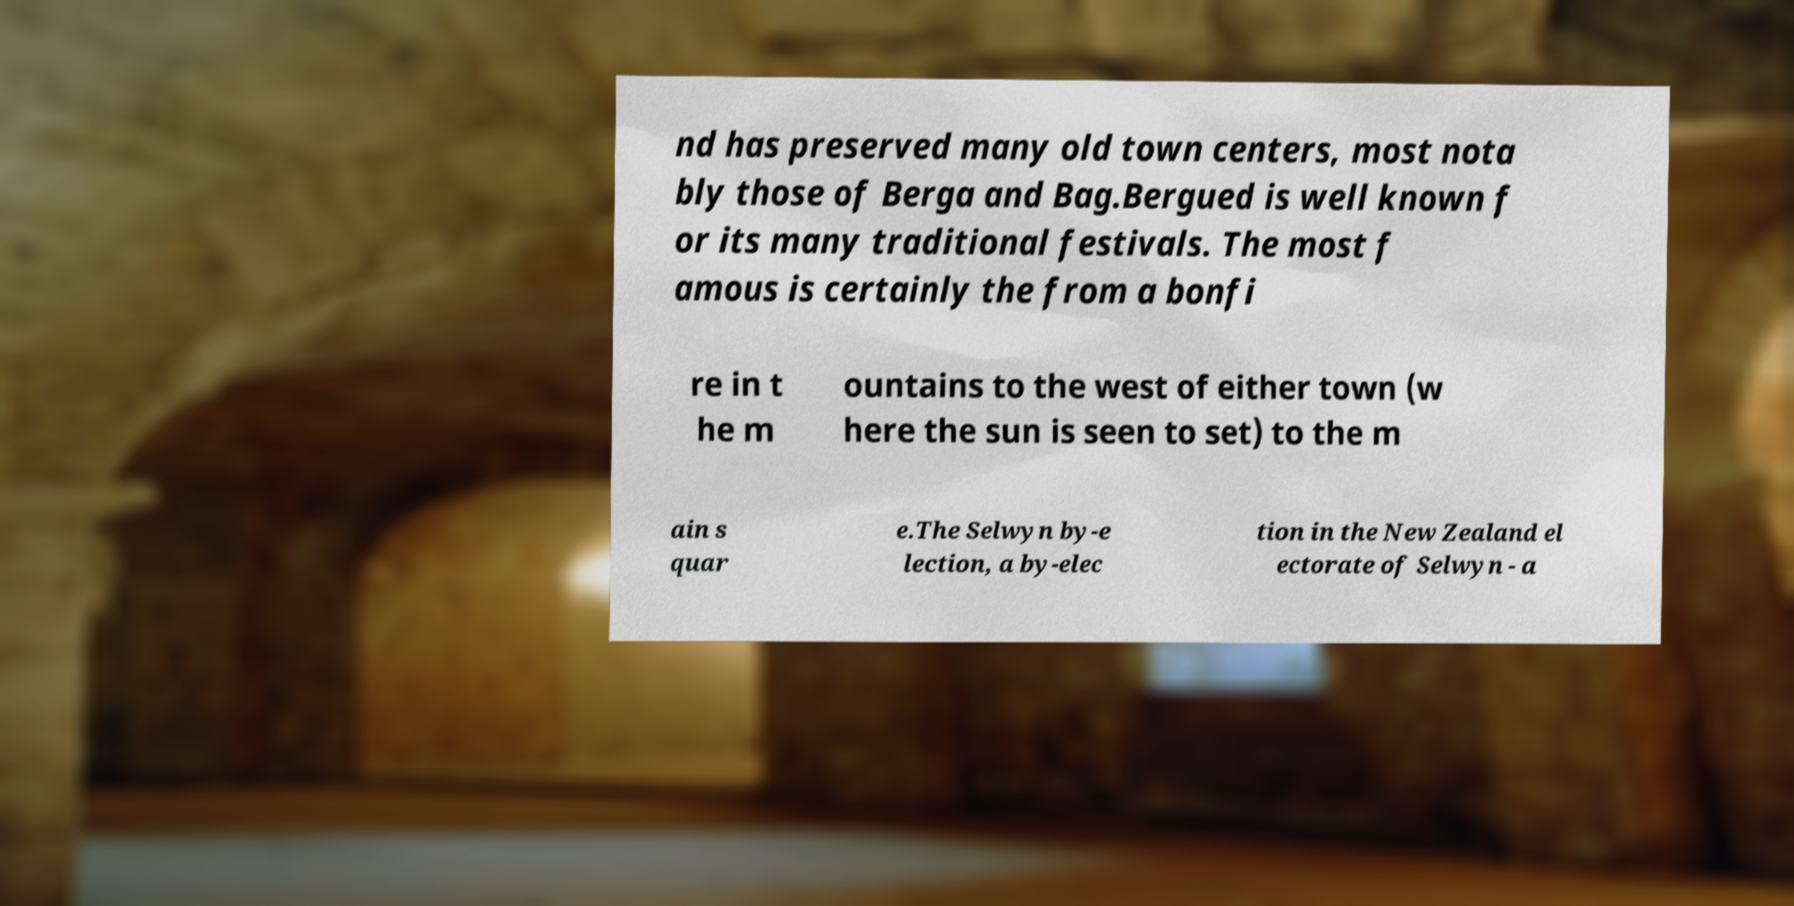Could you assist in decoding the text presented in this image and type it out clearly? nd has preserved many old town centers, most nota bly those of Berga and Bag.Bergued is well known f or its many traditional festivals. The most f amous is certainly the from a bonfi re in t he m ountains to the west of either town (w here the sun is seen to set) to the m ain s quar e.The Selwyn by-e lection, a by-elec tion in the New Zealand el ectorate of Selwyn - a 